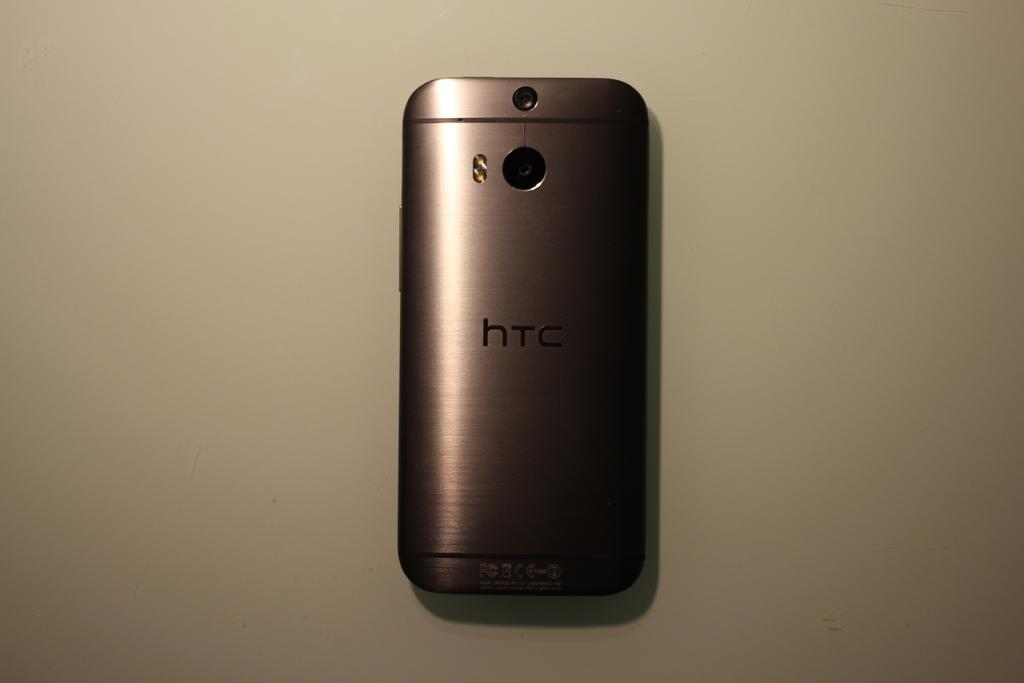<image>
Share a concise interpretation of the image provided. Back of a HTC phone with a camera and a chrome design. 